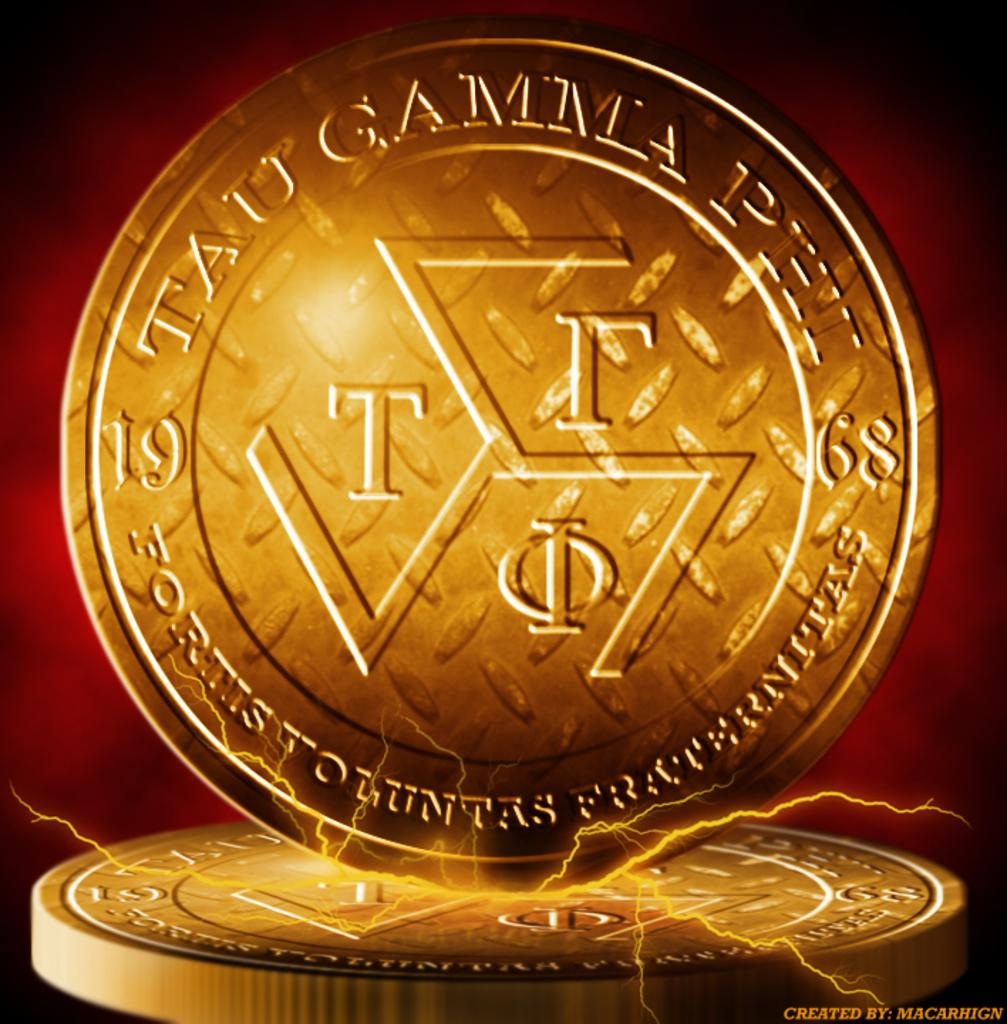<image>
Offer a succinct explanation of the picture presented. Gold coin for Tau Gamma Phi that was formed in 1968 